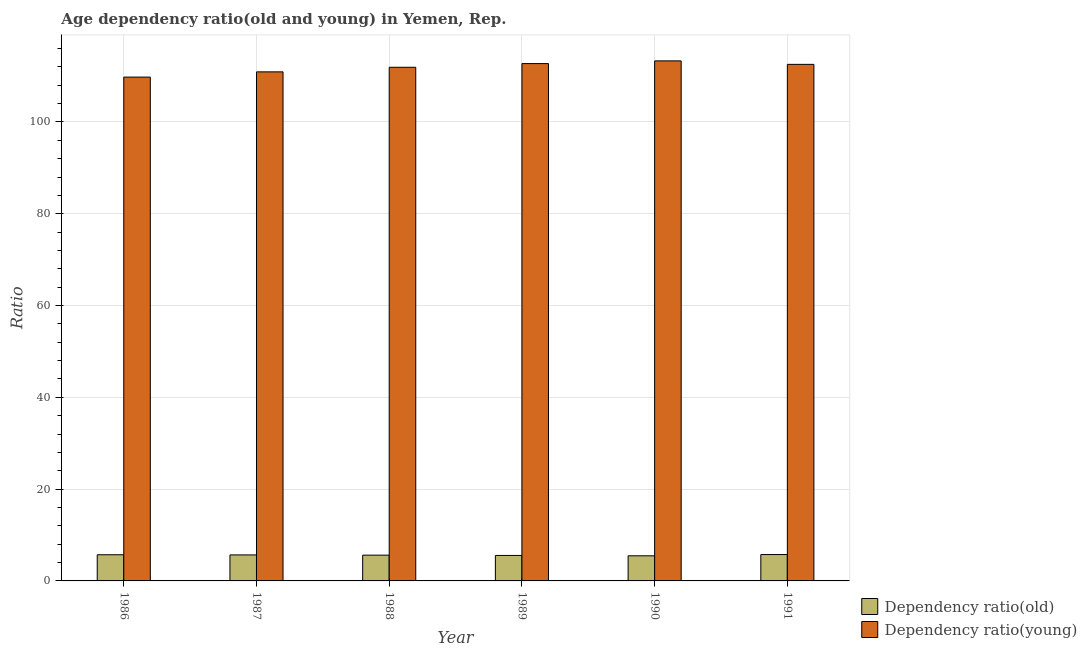How many groups of bars are there?
Your response must be concise. 6. Are the number of bars on each tick of the X-axis equal?
Your answer should be compact. Yes. How many bars are there on the 5th tick from the left?
Give a very brief answer. 2. How many bars are there on the 4th tick from the right?
Provide a succinct answer. 2. In how many cases, is the number of bars for a given year not equal to the number of legend labels?
Give a very brief answer. 0. What is the age dependency ratio(old) in 1990?
Give a very brief answer. 5.47. Across all years, what is the maximum age dependency ratio(young)?
Provide a short and direct response. 113.31. Across all years, what is the minimum age dependency ratio(young)?
Your answer should be very brief. 109.77. In which year was the age dependency ratio(young) minimum?
Offer a very short reply. 1986. What is the total age dependency ratio(young) in the graph?
Your answer should be compact. 671.18. What is the difference between the age dependency ratio(old) in 1987 and that in 1991?
Provide a succinct answer. -0.08. What is the difference between the age dependency ratio(old) in 1987 and the age dependency ratio(young) in 1989?
Provide a short and direct response. 0.12. What is the average age dependency ratio(young) per year?
Offer a terse response. 111.86. In the year 1989, what is the difference between the age dependency ratio(old) and age dependency ratio(young)?
Keep it short and to the point. 0. In how many years, is the age dependency ratio(young) greater than 12?
Make the answer very short. 6. What is the ratio of the age dependency ratio(young) in 1986 to that in 1990?
Ensure brevity in your answer.  0.97. Is the age dependency ratio(young) in 1987 less than that in 1991?
Your answer should be compact. Yes. What is the difference between the highest and the second highest age dependency ratio(young)?
Provide a short and direct response. 0.59. What is the difference between the highest and the lowest age dependency ratio(old)?
Give a very brief answer. 0.27. In how many years, is the age dependency ratio(old) greater than the average age dependency ratio(old) taken over all years?
Your response must be concise. 3. Is the sum of the age dependency ratio(old) in 1987 and 1990 greater than the maximum age dependency ratio(young) across all years?
Your response must be concise. Yes. What does the 1st bar from the left in 1988 represents?
Your response must be concise. Dependency ratio(old). What does the 2nd bar from the right in 1986 represents?
Offer a very short reply. Dependency ratio(old). What is the difference between two consecutive major ticks on the Y-axis?
Ensure brevity in your answer.  20. Does the graph contain any zero values?
Offer a terse response. No. Does the graph contain grids?
Provide a succinct answer. Yes. How many legend labels are there?
Your response must be concise. 2. How are the legend labels stacked?
Ensure brevity in your answer.  Vertical. What is the title of the graph?
Provide a short and direct response. Age dependency ratio(old and young) in Yemen, Rep. What is the label or title of the X-axis?
Provide a short and direct response. Year. What is the label or title of the Y-axis?
Keep it short and to the point. Ratio. What is the Ratio of Dependency ratio(old) in 1986?
Your response must be concise. 5.7. What is the Ratio in Dependency ratio(young) in 1986?
Provide a short and direct response. 109.77. What is the Ratio in Dependency ratio(old) in 1987?
Your answer should be very brief. 5.66. What is the Ratio in Dependency ratio(young) in 1987?
Your answer should be compact. 110.91. What is the Ratio in Dependency ratio(old) in 1988?
Your response must be concise. 5.61. What is the Ratio in Dependency ratio(young) in 1988?
Keep it short and to the point. 111.91. What is the Ratio in Dependency ratio(old) in 1989?
Make the answer very short. 5.55. What is the Ratio of Dependency ratio(young) in 1989?
Make the answer very short. 112.72. What is the Ratio in Dependency ratio(old) in 1990?
Provide a succinct answer. 5.47. What is the Ratio in Dependency ratio(young) in 1990?
Your answer should be very brief. 113.31. What is the Ratio in Dependency ratio(old) in 1991?
Provide a short and direct response. 5.74. What is the Ratio of Dependency ratio(young) in 1991?
Keep it short and to the point. 112.55. Across all years, what is the maximum Ratio in Dependency ratio(old)?
Provide a short and direct response. 5.74. Across all years, what is the maximum Ratio in Dependency ratio(young)?
Offer a very short reply. 113.31. Across all years, what is the minimum Ratio in Dependency ratio(old)?
Keep it short and to the point. 5.47. Across all years, what is the minimum Ratio in Dependency ratio(young)?
Ensure brevity in your answer.  109.77. What is the total Ratio in Dependency ratio(old) in the graph?
Offer a terse response. 33.75. What is the total Ratio in Dependency ratio(young) in the graph?
Ensure brevity in your answer.  671.18. What is the difference between the Ratio of Dependency ratio(old) in 1986 and that in 1987?
Make the answer very short. 0.04. What is the difference between the Ratio of Dependency ratio(young) in 1986 and that in 1987?
Make the answer very short. -1.14. What is the difference between the Ratio in Dependency ratio(old) in 1986 and that in 1988?
Offer a very short reply. 0.09. What is the difference between the Ratio of Dependency ratio(young) in 1986 and that in 1988?
Your response must be concise. -2.14. What is the difference between the Ratio of Dependency ratio(old) in 1986 and that in 1989?
Make the answer very short. 0.15. What is the difference between the Ratio of Dependency ratio(young) in 1986 and that in 1989?
Provide a short and direct response. -2.94. What is the difference between the Ratio in Dependency ratio(old) in 1986 and that in 1990?
Your answer should be compact. 0.23. What is the difference between the Ratio of Dependency ratio(young) in 1986 and that in 1990?
Provide a succinct answer. -3.53. What is the difference between the Ratio of Dependency ratio(old) in 1986 and that in 1991?
Offer a terse response. -0.04. What is the difference between the Ratio of Dependency ratio(young) in 1986 and that in 1991?
Provide a succinct answer. -2.77. What is the difference between the Ratio of Dependency ratio(old) in 1987 and that in 1988?
Your answer should be compact. 0.05. What is the difference between the Ratio in Dependency ratio(young) in 1987 and that in 1988?
Keep it short and to the point. -1. What is the difference between the Ratio of Dependency ratio(old) in 1987 and that in 1989?
Make the answer very short. 0.12. What is the difference between the Ratio in Dependency ratio(young) in 1987 and that in 1989?
Your answer should be compact. -1.8. What is the difference between the Ratio in Dependency ratio(old) in 1987 and that in 1990?
Your answer should be compact. 0.19. What is the difference between the Ratio in Dependency ratio(young) in 1987 and that in 1990?
Offer a terse response. -2.39. What is the difference between the Ratio of Dependency ratio(old) in 1987 and that in 1991?
Give a very brief answer. -0.08. What is the difference between the Ratio in Dependency ratio(young) in 1987 and that in 1991?
Your answer should be very brief. -1.63. What is the difference between the Ratio in Dependency ratio(old) in 1988 and that in 1989?
Ensure brevity in your answer.  0.06. What is the difference between the Ratio of Dependency ratio(young) in 1988 and that in 1989?
Your answer should be very brief. -0.8. What is the difference between the Ratio of Dependency ratio(old) in 1988 and that in 1990?
Make the answer very short. 0.14. What is the difference between the Ratio of Dependency ratio(young) in 1988 and that in 1990?
Offer a terse response. -1.39. What is the difference between the Ratio in Dependency ratio(old) in 1988 and that in 1991?
Ensure brevity in your answer.  -0.13. What is the difference between the Ratio in Dependency ratio(young) in 1988 and that in 1991?
Provide a short and direct response. -0.63. What is the difference between the Ratio in Dependency ratio(old) in 1989 and that in 1990?
Give a very brief answer. 0.08. What is the difference between the Ratio in Dependency ratio(young) in 1989 and that in 1990?
Make the answer very short. -0.59. What is the difference between the Ratio of Dependency ratio(old) in 1989 and that in 1991?
Provide a succinct answer. -0.19. What is the difference between the Ratio in Dependency ratio(young) in 1989 and that in 1991?
Offer a terse response. 0.17. What is the difference between the Ratio in Dependency ratio(old) in 1990 and that in 1991?
Offer a terse response. -0.27. What is the difference between the Ratio of Dependency ratio(young) in 1990 and that in 1991?
Give a very brief answer. 0.76. What is the difference between the Ratio in Dependency ratio(old) in 1986 and the Ratio in Dependency ratio(young) in 1987?
Offer a terse response. -105.21. What is the difference between the Ratio of Dependency ratio(old) in 1986 and the Ratio of Dependency ratio(young) in 1988?
Your answer should be compact. -106.21. What is the difference between the Ratio in Dependency ratio(old) in 1986 and the Ratio in Dependency ratio(young) in 1989?
Your answer should be compact. -107.02. What is the difference between the Ratio of Dependency ratio(old) in 1986 and the Ratio of Dependency ratio(young) in 1990?
Make the answer very short. -107.61. What is the difference between the Ratio of Dependency ratio(old) in 1986 and the Ratio of Dependency ratio(young) in 1991?
Provide a succinct answer. -106.85. What is the difference between the Ratio of Dependency ratio(old) in 1987 and the Ratio of Dependency ratio(young) in 1988?
Your answer should be compact. -106.25. What is the difference between the Ratio of Dependency ratio(old) in 1987 and the Ratio of Dependency ratio(young) in 1989?
Give a very brief answer. -107.05. What is the difference between the Ratio in Dependency ratio(old) in 1987 and the Ratio in Dependency ratio(young) in 1990?
Offer a very short reply. -107.64. What is the difference between the Ratio in Dependency ratio(old) in 1987 and the Ratio in Dependency ratio(young) in 1991?
Your answer should be very brief. -106.88. What is the difference between the Ratio of Dependency ratio(old) in 1988 and the Ratio of Dependency ratio(young) in 1989?
Your answer should be very brief. -107.1. What is the difference between the Ratio in Dependency ratio(old) in 1988 and the Ratio in Dependency ratio(young) in 1990?
Offer a terse response. -107.69. What is the difference between the Ratio in Dependency ratio(old) in 1988 and the Ratio in Dependency ratio(young) in 1991?
Provide a short and direct response. -106.93. What is the difference between the Ratio in Dependency ratio(old) in 1989 and the Ratio in Dependency ratio(young) in 1990?
Make the answer very short. -107.76. What is the difference between the Ratio of Dependency ratio(old) in 1989 and the Ratio of Dependency ratio(young) in 1991?
Ensure brevity in your answer.  -107. What is the difference between the Ratio of Dependency ratio(old) in 1990 and the Ratio of Dependency ratio(young) in 1991?
Give a very brief answer. -107.08. What is the average Ratio in Dependency ratio(old) per year?
Your answer should be compact. 5.62. What is the average Ratio of Dependency ratio(young) per year?
Your answer should be very brief. 111.86. In the year 1986, what is the difference between the Ratio in Dependency ratio(old) and Ratio in Dependency ratio(young)?
Give a very brief answer. -104.07. In the year 1987, what is the difference between the Ratio of Dependency ratio(old) and Ratio of Dependency ratio(young)?
Give a very brief answer. -105.25. In the year 1988, what is the difference between the Ratio of Dependency ratio(old) and Ratio of Dependency ratio(young)?
Your answer should be compact. -106.3. In the year 1989, what is the difference between the Ratio of Dependency ratio(old) and Ratio of Dependency ratio(young)?
Your response must be concise. -107.17. In the year 1990, what is the difference between the Ratio in Dependency ratio(old) and Ratio in Dependency ratio(young)?
Make the answer very short. -107.84. In the year 1991, what is the difference between the Ratio of Dependency ratio(old) and Ratio of Dependency ratio(young)?
Offer a very short reply. -106.8. What is the ratio of the Ratio of Dependency ratio(old) in 1986 to that in 1988?
Offer a very short reply. 1.02. What is the ratio of the Ratio of Dependency ratio(young) in 1986 to that in 1988?
Make the answer very short. 0.98. What is the ratio of the Ratio of Dependency ratio(old) in 1986 to that in 1989?
Offer a very short reply. 1.03. What is the ratio of the Ratio in Dependency ratio(young) in 1986 to that in 1989?
Provide a succinct answer. 0.97. What is the ratio of the Ratio of Dependency ratio(old) in 1986 to that in 1990?
Your answer should be compact. 1.04. What is the ratio of the Ratio in Dependency ratio(young) in 1986 to that in 1990?
Ensure brevity in your answer.  0.97. What is the ratio of the Ratio in Dependency ratio(young) in 1986 to that in 1991?
Offer a terse response. 0.98. What is the ratio of the Ratio of Dependency ratio(old) in 1987 to that in 1989?
Provide a succinct answer. 1.02. What is the ratio of the Ratio of Dependency ratio(old) in 1987 to that in 1990?
Keep it short and to the point. 1.04. What is the ratio of the Ratio in Dependency ratio(young) in 1987 to that in 1990?
Your answer should be very brief. 0.98. What is the ratio of the Ratio of Dependency ratio(old) in 1987 to that in 1991?
Your answer should be compact. 0.99. What is the ratio of the Ratio of Dependency ratio(young) in 1987 to that in 1991?
Your response must be concise. 0.99. What is the ratio of the Ratio in Dependency ratio(old) in 1988 to that in 1989?
Provide a short and direct response. 1.01. What is the ratio of the Ratio in Dependency ratio(young) in 1988 to that in 1989?
Ensure brevity in your answer.  0.99. What is the ratio of the Ratio in Dependency ratio(old) in 1988 to that in 1990?
Offer a terse response. 1.03. What is the ratio of the Ratio of Dependency ratio(young) in 1988 to that in 1990?
Offer a very short reply. 0.99. What is the ratio of the Ratio in Dependency ratio(old) in 1988 to that in 1991?
Give a very brief answer. 0.98. What is the ratio of the Ratio in Dependency ratio(young) in 1988 to that in 1991?
Keep it short and to the point. 0.99. What is the ratio of the Ratio in Dependency ratio(old) in 1989 to that in 1990?
Provide a short and direct response. 1.01. What is the ratio of the Ratio of Dependency ratio(old) in 1989 to that in 1991?
Ensure brevity in your answer.  0.97. What is the ratio of the Ratio in Dependency ratio(young) in 1989 to that in 1991?
Your answer should be very brief. 1. What is the ratio of the Ratio in Dependency ratio(old) in 1990 to that in 1991?
Offer a terse response. 0.95. What is the ratio of the Ratio of Dependency ratio(young) in 1990 to that in 1991?
Your response must be concise. 1.01. What is the difference between the highest and the second highest Ratio of Dependency ratio(old)?
Provide a short and direct response. 0.04. What is the difference between the highest and the second highest Ratio of Dependency ratio(young)?
Keep it short and to the point. 0.59. What is the difference between the highest and the lowest Ratio in Dependency ratio(old)?
Offer a terse response. 0.27. What is the difference between the highest and the lowest Ratio of Dependency ratio(young)?
Provide a short and direct response. 3.53. 